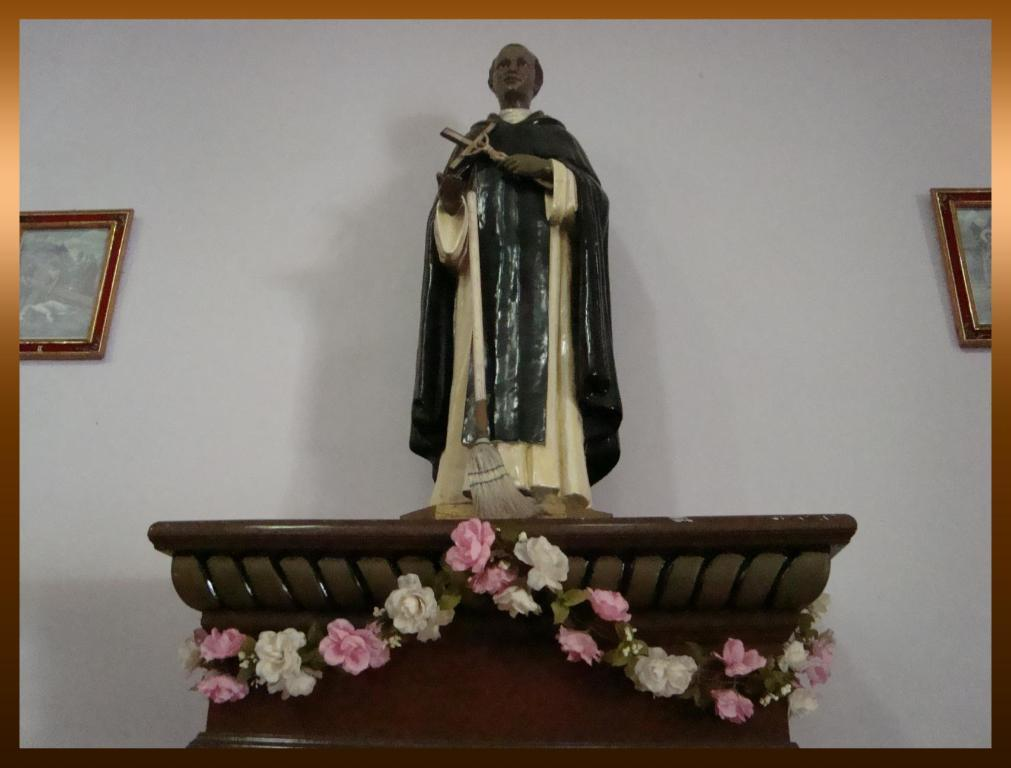What is the man idol holding in the image? The man idol is holding a cross in the image. Where is the man idol located in the image? The man idol is standing on a desk in the image. What can be seen on the desk in the image? The desk is decorated with flowers in the image. What is visible on the wall in the background of the image? There are two photo frames on the wall in the background of the image. What type of stocking is the man idol wearing in the image? The man idol is not wearing any stockings in the image. What rule is being enforced by the man idol in the image? The man idol is not enforcing any rules in the image; it is a statue or idol. 